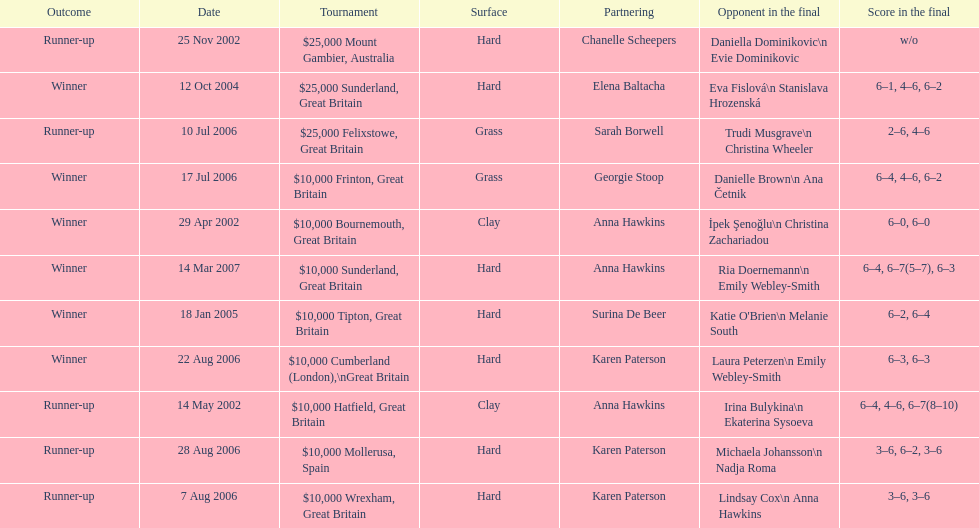What is the number of prize money for the 14 may 2002 tournament? $10,000. 